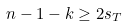<formula> <loc_0><loc_0><loc_500><loc_500>n - 1 - k \geq 2 s _ { T }</formula> 